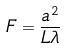Convert formula to latex. <formula><loc_0><loc_0><loc_500><loc_500>F = \frac { a ^ { 2 } } { L \lambda }</formula> 